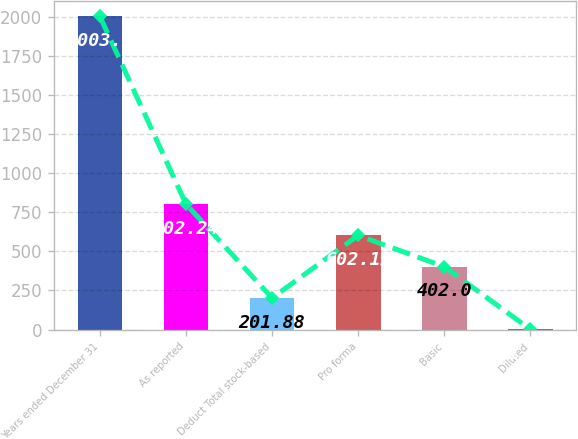Convert chart. <chart><loc_0><loc_0><loc_500><loc_500><bar_chart><fcel>Years ended December 31<fcel>As reported<fcel>Deduct Total stock-based<fcel>Pro forma<fcel>Basic<fcel>Diluted<nl><fcel>2003<fcel>802.24<fcel>201.88<fcel>602.12<fcel>402<fcel>1.76<nl></chart> 